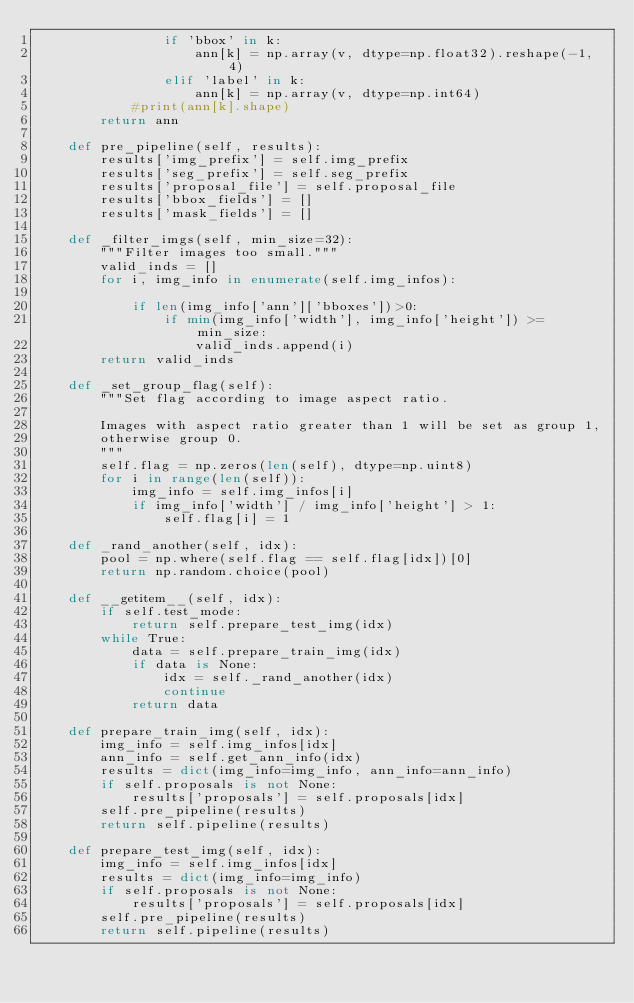<code> <loc_0><loc_0><loc_500><loc_500><_Python_>                if 'bbox' in k:
                    ann[k] = np.array(v, dtype=np.float32).reshape(-1, 4)
                elif 'label' in k:
                    ann[k] = np.array(v, dtype=np.int64)
            #print(ann[k].shape)
        return ann

    def pre_pipeline(self, results):
        results['img_prefix'] = self.img_prefix
        results['seg_prefix'] = self.seg_prefix
        results['proposal_file'] = self.proposal_file
        results['bbox_fields'] = []
        results['mask_fields'] = []

    def _filter_imgs(self, min_size=32):
        """Filter images too small."""
        valid_inds = []
        for i, img_info in enumerate(self.img_infos):

            if len(img_info['ann']['bboxes'])>0:
                if min(img_info['width'], img_info['height']) >= min_size:
                    valid_inds.append(i)
        return valid_inds

    def _set_group_flag(self):
        """Set flag according to image aspect ratio.

        Images with aspect ratio greater than 1 will be set as group 1,
        otherwise group 0.
        """
        self.flag = np.zeros(len(self), dtype=np.uint8)
        for i in range(len(self)):
            img_info = self.img_infos[i]
            if img_info['width'] / img_info['height'] > 1:
                self.flag[i] = 1

    def _rand_another(self, idx):
        pool = np.where(self.flag == self.flag[idx])[0]
        return np.random.choice(pool)

    def __getitem__(self, idx):
        if self.test_mode:
            return self.prepare_test_img(idx)
        while True:
            data = self.prepare_train_img(idx)
            if data is None:
                idx = self._rand_another(idx)
                continue
            return data

    def prepare_train_img(self, idx):
        img_info = self.img_infos[idx]
        ann_info = self.get_ann_info(idx)
        results = dict(img_info=img_info, ann_info=ann_info)
        if self.proposals is not None:
            results['proposals'] = self.proposals[idx]
        self.pre_pipeline(results)
        return self.pipeline(results)

    def prepare_test_img(self, idx):
        img_info = self.img_infos[idx]
        results = dict(img_info=img_info)
        if self.proposals is not None:
            results['proposals'] = self.proposals[idx]
        self.pre_pipeline(results)
        return self.pipeline(results)
</code> 